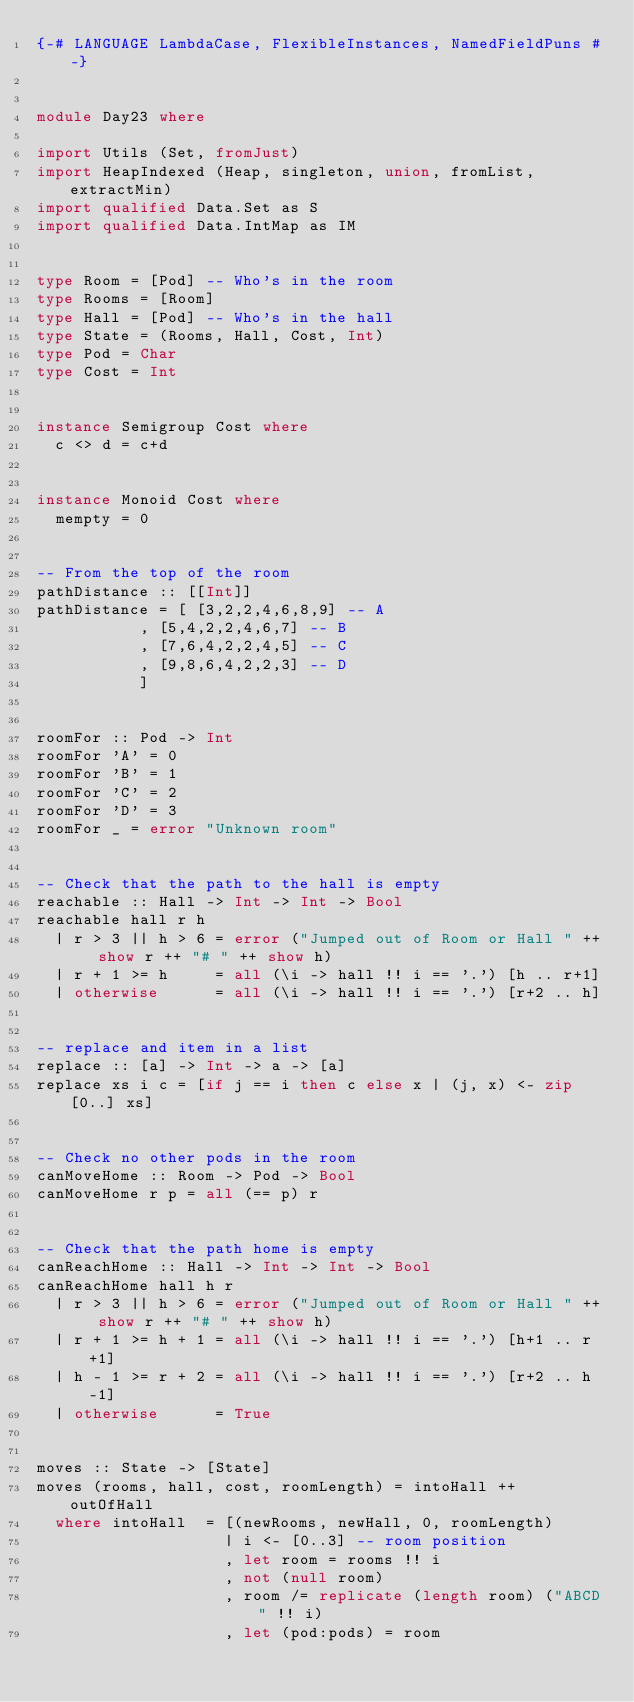Convert code to text. <code><loc_0><loc_0><loc_500><loc_500><_Haskell_>{-# LANGUAGE LambdaCase, FlexibleInstances, NamedFieldPuns #-}


module Day23 where

import Utils (Set, fromJust)
import HeapIndexed (Heap, singleton, union, fromList, extractMin)
import qualified Data.Set as S
import qualified Data.IntMap as IM


type Room = [Pod] -- Who's in the room
type Rooms = [Room]
type Hall = [Pod] -- Who's in the hall
type State = (Rooms, Hall, Cost, Int)
type Pod = Char
type Cost = Int


instance Semigroup Cost where
  c <> d = c+d


instance Monoid Cost where
  mempty = 0


-- From the top of the room
pathDistance :: [[Int]]
pathDistance = [ [3,2,2,4,6,8,9] -- A
           , [5,4,2,2,4,6,7] -- B
           , [7,6,4,2,2,4,5] -- C
           , [9,8,6,4,2,2,3] -- D
           ]


roomFor :: Pod -> Int
roomFor 'A' = 0
roomFor 'B' = 1
roomFor 'C' = 2
roomFor 'D' = 3
roomFor _ = error "Unknown room"


-- Check that the path to the hall is empty
reachable :: Hall -> Int -> Int -> Bool
reachable hall r h
  | r > 3 || h > 6 = error ("Jumped out of Room or Hall " ++ show r ++ "# " ++ show h)
  | r + 1 >= h     = all (\i -> hall !! i == '.') [h .. r+1]
  | otherwise      = all (\i -> hall !! i == '.') [r+2 .. h]


-- replace and item in a list
replace :: [a] -> Int -> a -> [a]
replace xs i c = [if j == i then c else x | (j, x) <- zip [0..] xs]


-- Check no other pods in the room
canMoveHome :: Room -> Pod -> Bool
canMoveHome r p = all (== p) r


-- Check that the path home is empty
canReachHome :: Hall -> Int -> Int -> Bool
canReachHome hall h r
  | r > 3 || h > 6 = error ("Jumped out of Room or Hall " ++ show r ++ "# " ++ show h)
  | r + 1 >= h + 1 = all (\i -> hall !! i == '.') [h+1 .. r+1]
  | h - 1 >= r + 2 = all (\i -> hall !! i == '.') [r+2 .. h-1]
  | otherwise      = True


moves :: State -> [State]
moves (rooms, hall, cost, roomLength) = intoHall ++ outOfHall
  where intoHall  = [(newRooms, newHall, 0, roomLength)
                    | i <- [0..3] -- room position
                    , let room = rooms !! i
                    , not (null room)
                    , room /= replicate (length room) ("ABCD" !! i)
                    , let (pod:pods) = room</code> 